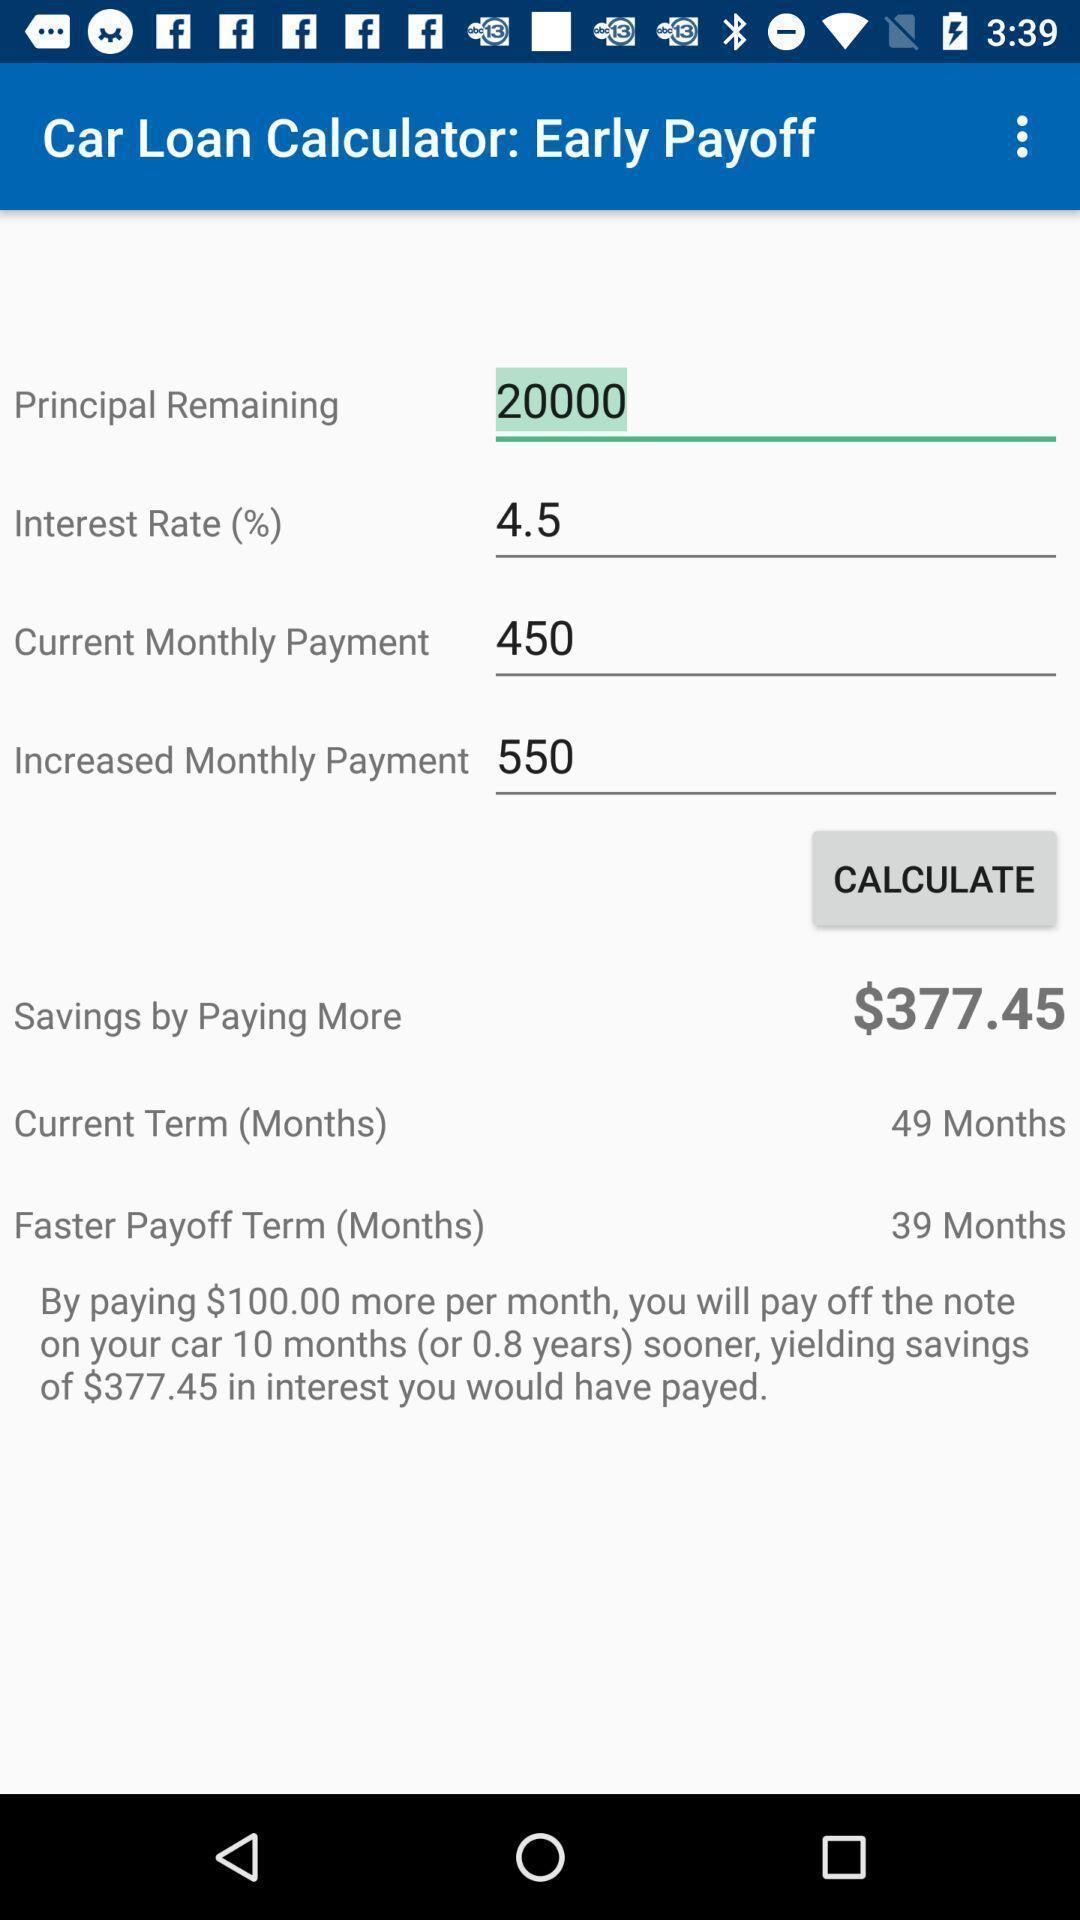Describe the key features of this screenshot. Screen shows loan calculator page in the application. 